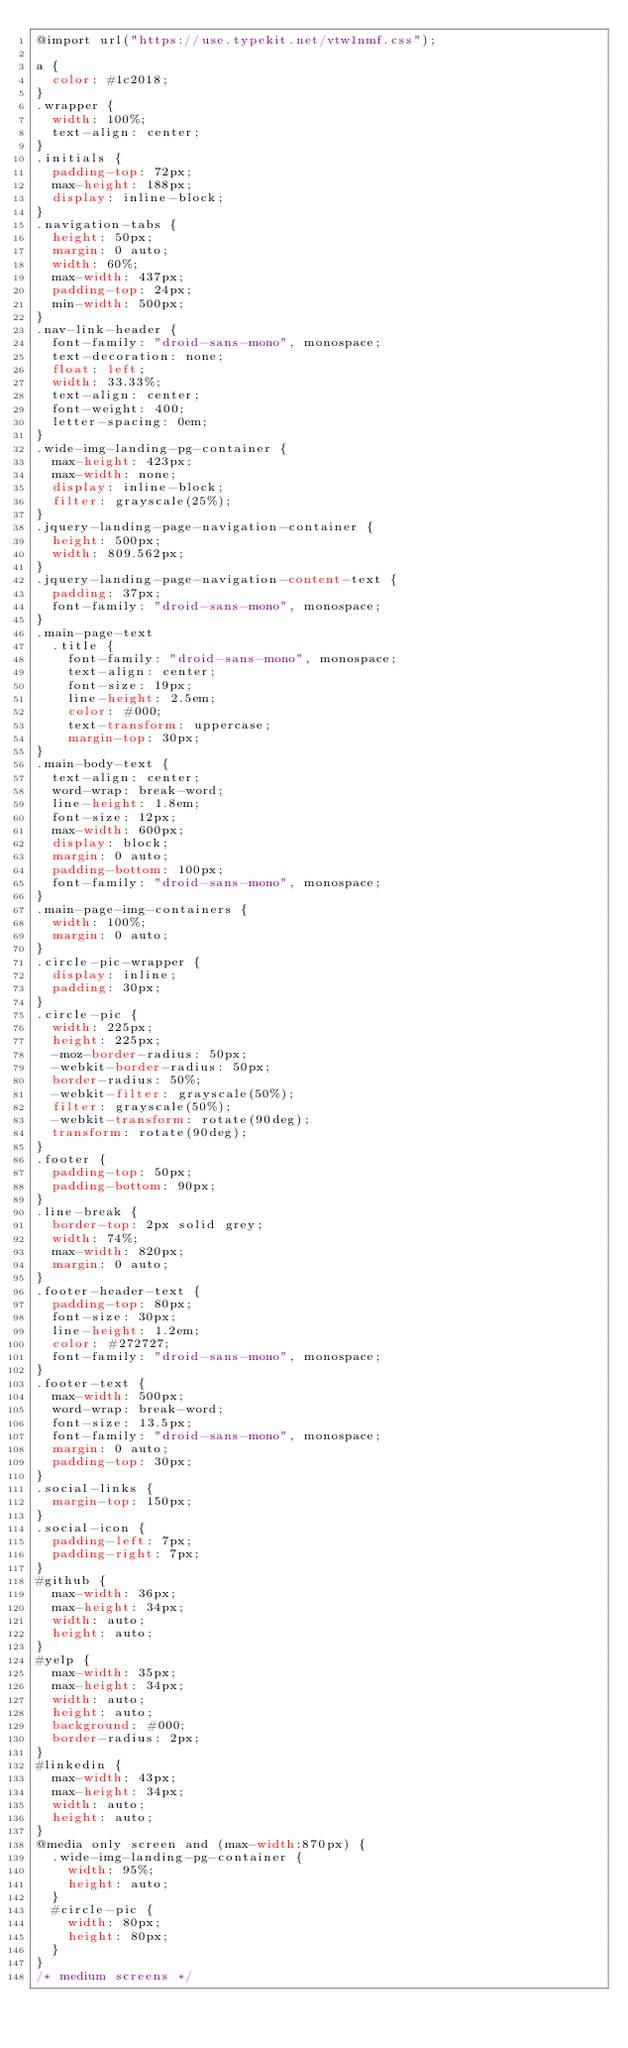<code> <loc_0><loc_0><loc_500><loc_500><_CSS_>@import url("https://use.typekit.net/vtw1nmf.css");

a {
  color: #1c2018;
}
.wrapper {
  width: 100%;
  text-align: center;
}
.initials {
  padding-top: 72px;
  max-height: 188px;
  display: inline-block;
}
.navigation-tabs {
  height: 50px;
  margin: 0 auto;
  width: 60%;
  max-width: 437px;
  padding-top: 24px;
  min-width: 500px;
}
.nav-link-header {
  font-family: "droid-sans-mono", monospace;
  text-decoration: none;
  float: left;
  width: 33.33%;
  text-align: center;
  font-weight: 400;
  letter-spacing: 0em;
}
.wide-img-landing-pg-container {
  max-height: 423px;
  max-width: none;
  display: inline-block;
  filter: grayscale(25%);
}
.jquery-landing-page-navigation-container {
  height: 500px;
  width: 809.562px;
}
.jquery-landing-page-navigation-content-text {
  padding: 37px;
  font-family: "droid-sans-mono", monospace;
}
.main-page-text 
  .title {
    font-family: "droid-sans-mono", monospace;
    text-align: center;
    font-size: 19px;
    line-height: 2.5em;
    color: #000;
    text-transform: uppercase;
    margin-top: 30px;
}
.main-body-text {
  text-align: center;
  word-wrap: break-word;
  line-height: 1.8em;
  font-size: 12px;
  max-width: 600px;
  display: block;
  margin: 0 auto;
  padding-bottom: 100px;
  font-family: "droid-sans-mono", monospace;
}
.main-page-img-containers {
  width: 100%;
  margin: 0 auto;
}
.circle-pic-wrapper {
  display: inline;
  padding: 30px;
}
.circle-pic {
  width: 225px;
  height: 225px;
  -moz-border-radius: 50px;
  -webkit-border-radius: 50px;
  border-radius: 50%;
  -webkit-filter: grayscale(50%);
  filter: grayscale(50%);
  -webkit-transform: rotate(90deg);
  transform: rotate(90deg);
}
.footer {
  padding-top: 50px;
  padding-bottom: 90px;
}
.line-break {
  border-top: 2px solid grey;
  width: 74%;
  max-width: 820px;
  margin: 0 auto;
}
.footer-header-text {
  padding-top: 80px;
  font-size: 30px;
  line-height: 1.2em;
  color: #272727;
  font-family: "droid-sans-mono", monospace;
}
.footer-text {
  max-width: 500px;
  word-wrap: break-word;
  font-size: 13.5px;
  font-family: "droid-sans-mono", monospace;
  margin: 0 auto;
  padding-top: 30px;
}
.social-links {
  margin-top: 150px;
}
.social-icon {
  padding-left: 7px;
  padding-right: 7px;
}
#github {
  max-width: 36px;
  max-height: 34px;
  width: auto;
  height: auto;
}
#yelp {
  max-width: 35px;
  max-height: 34px;
  width: auto;
  height: auto;
  background: #000;
  border-radius: 2px;
}
#linkedin {
  max-width: 43px;
  max-height: 34px;
  width: auto;
  height: auto;
}
@media only screen and (max-width:870px) {
  .wide-img-landing-pg-container {
    width: 95%;
    height: auto;
  }
  #circle-pic {
    width: 80px;
    height: 80px;
  }
}
/* medium screens */</code> 